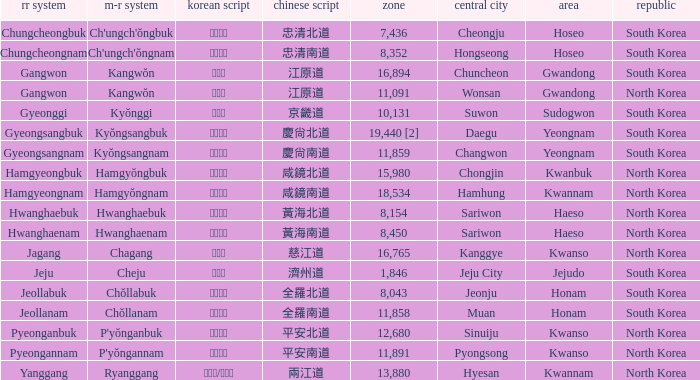Which country has a city with a Hanja of 平安北道? North Korea. 